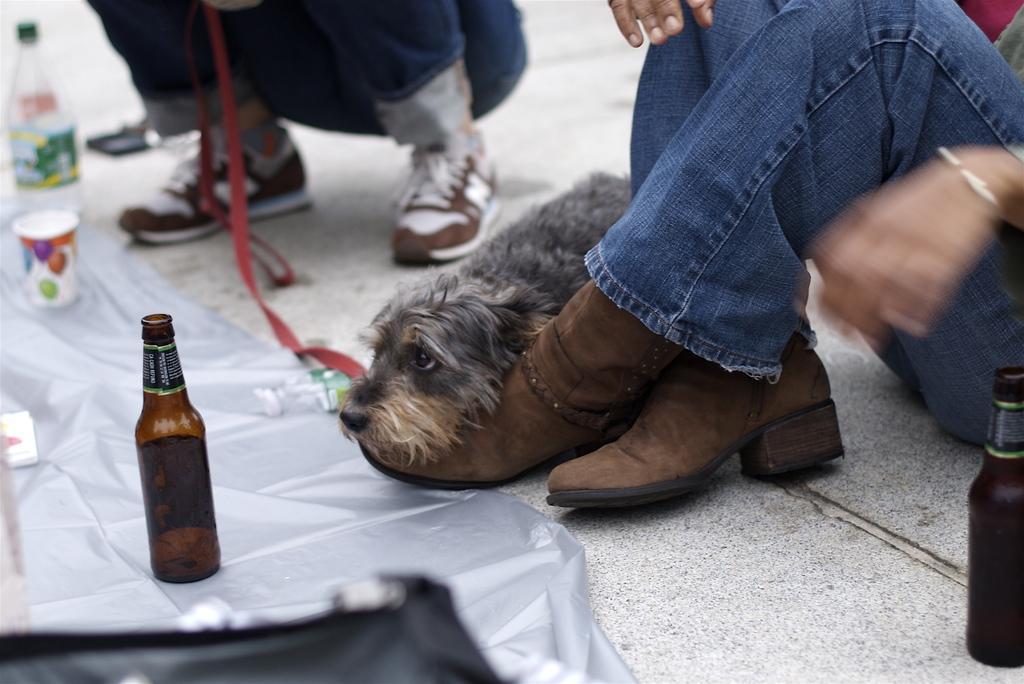Please provide a concise description of this image. In this picture we can see bottles, glass on a cover. We can see water bottle , puppy on the floor and two persons here. 